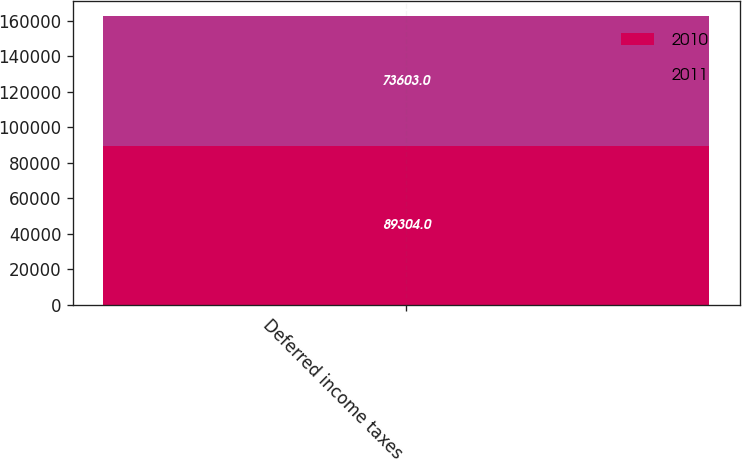Convert chart to OTSL. <chart><loc_0><loc_0><loc_500><loc_500><stacked_bar_chart><ecel><fcel>Deferred income taxes<nl><fcel>2010<fcel>89304<nl><fcel>2011<fcel>73603<nl></chart> 